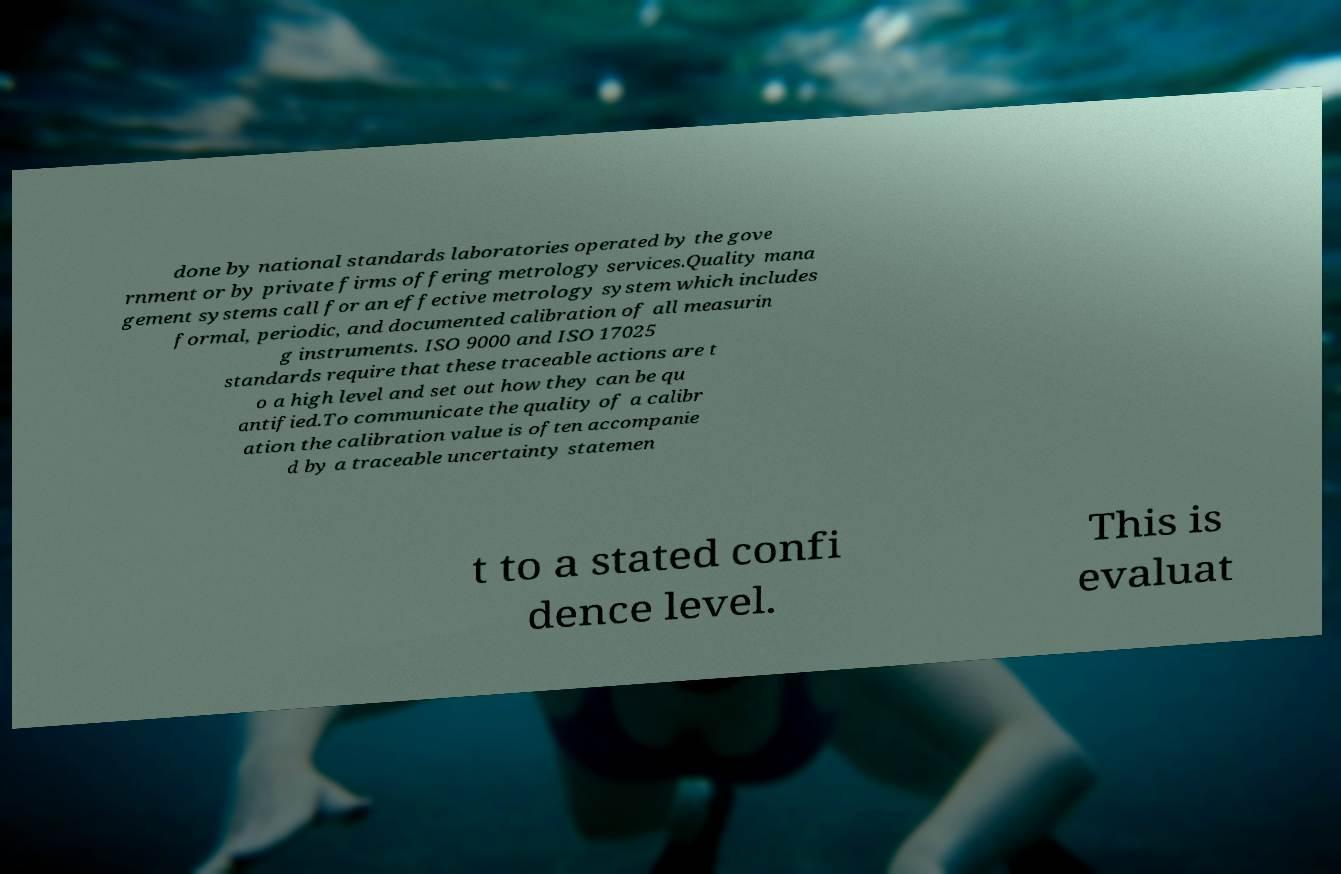Could you extract and type out the text from this image? done by national standards laboratories operated by the gove rnment or by private firms offering metrology services.Quality mana gement systems call for an effective metrology system which includes formal, periodic, and documented calibration of all measurin g instruments. ISO 9000 and ISO 17025 standards require that these traceable actions are t o a high level and set out how they can be qu antified.To communicate the quality of a calibr ation the calibration value is often accompanie d by a traceable uncertainty statemen t to a stated confi dence level. This is evaluat 